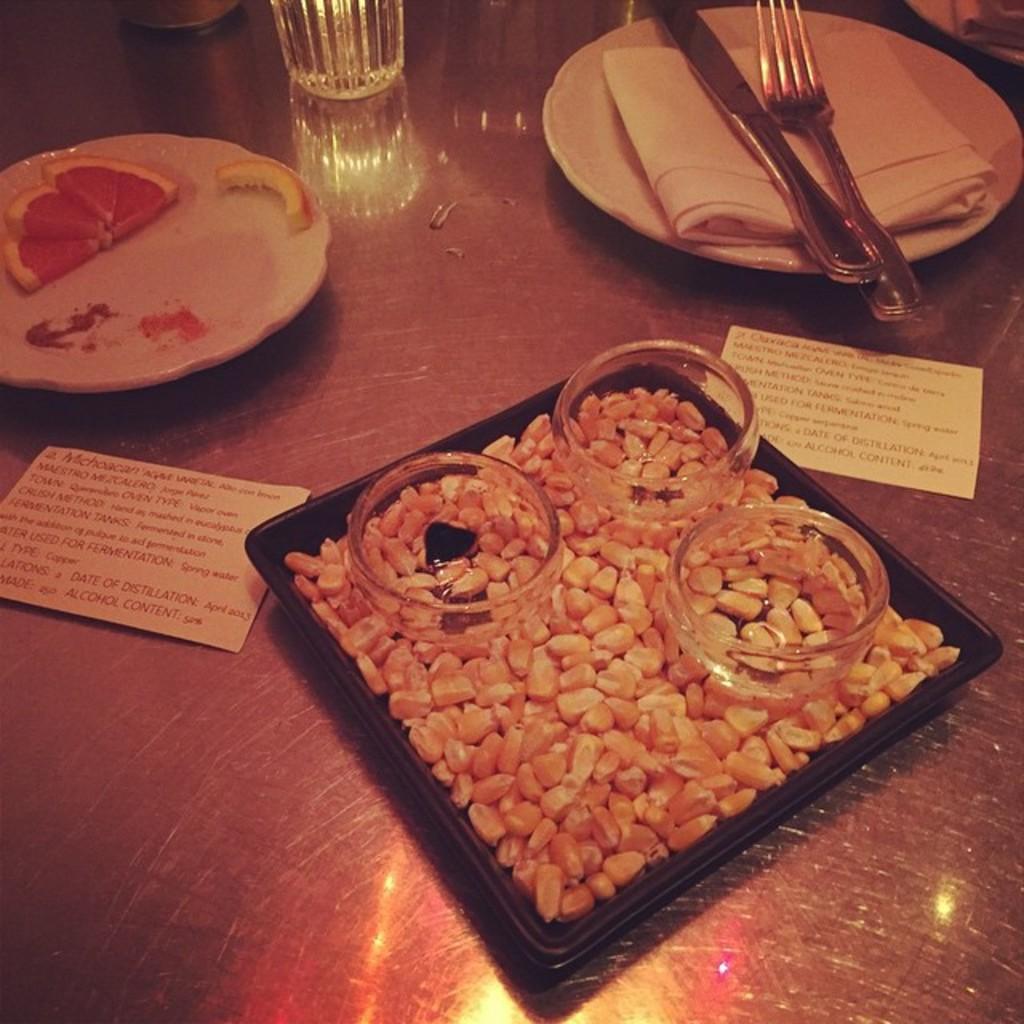Could you give a brief overview of what you see in this image? On this surface we can see plates, knife, fork, bowls, glass, cards and food. 